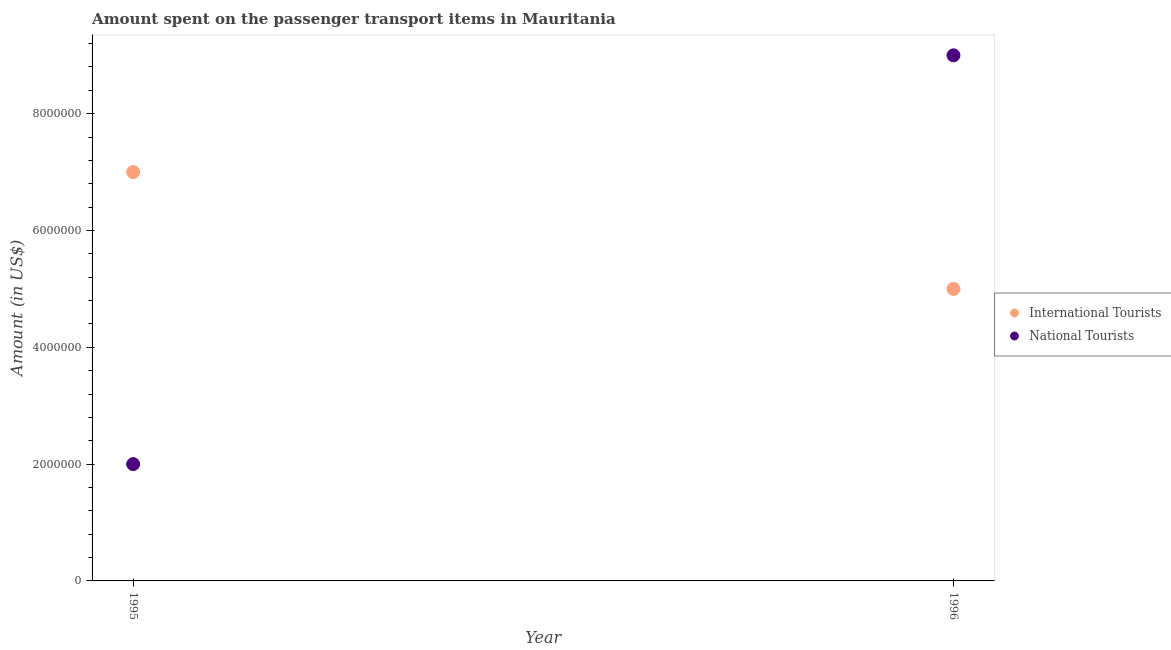How many different coloured dotlines are there?
Your answer should be very brief. 2. Is the number of dotlines equal to the number of legend labels?
Provide a short and direct response. Yes. What is the amount spent on transport items of international tourists in 1996?
Ensure brevity in your answer.  5.00e+06. Across all years, what is the maximum amount spent on transport items of international tourists?
Your answer should be very brief. 7.00e+06. Across all years, what is the minimum amount spent on transport items of international tourists?
Offer a terse response. 5.00e+06. In which year was the amount spent on transport items of international tourists maximum?
Provide a succinct answer. 1995. What is the total amount spent on transport items of national tourists in the graph?
Provide a short and direct response. 1.10e+07. What is the difference between the amount spent on transport items of national tourists in 1995 and that in 1996?
Keep it short and to the point. -7.00e+06. What is the difference between the amount spent on transport items of national tourists in 1996 and the amount spent on transport items of international tourists in 1995?
Offer a very short reply. 2.00e+06. What is the average amount spent on transport items of national tourists per year?
Provide a succinct answer. 5.50e+06. In the year 1996, what is the difference between the amount spent on transport items of international tourists and amount spent on transport items of national tourists?
Ensure brevity in your answer.  -4.00e+06. In how many years, is the amount spent on transport items of international tourists greater than 8800000 US$?
Offer a terse response. 0. What is the ratio of the amount spent on transport items of national tourists in 1995 to that in 1996?
Keep it short and to the point. 0.22. In how many years, is the amount spent on transport items of international tourists greater than the average amount spent on transport items of international tourists taken over all years?
Your answer should be compact. 1. Does the amount spent on transport items of international tourists monotonically increase over the years?
Give a very brief answer. No. Is the amount spent on transport items of international tourists strictly less than the amount spent on transport items of national tourists over the years?
Your response must be concise. No. How many dotlines are there?
Your response must be concise. 2. Are the values on the major ticks of Y-axis written in scientific E-notation?
Ensure brevity in your answer.  No. Does the graph contain grids?
Offer a terse response. No. How many legend labels are there?
Ensure brevity in your answer.  2. What is the title of the graph?
Provide a short and direct response. Amount spent on the passenger transport items in Mauritania. What is the label or title of the Y-axis?
Make the answer very short. Amount (in US$). What is the Amount (in US$) in International Tourists in 1995?
Your response must be concise. 7.00e+06. What is the Amount (in US$) of National Tourists in 1996?
Offer a terse response. 9.00e+06. Across all years, what is the maximum Amount (in US$) in National Tourists?
Provide a short and direct response. 9.00e+06. Across all years, what is the minimum Amount (in US$) of National Tourists?
Ensure brevity in your answer.  2.00e+06. What is the total Amount (in US$) of National Tourists in the graph?
Provide a succinct answer. 1.10e+07. What is the difference between the Amount (in US$) of National Tourists in 1995 and that in 1996?
Offer a terse response. -7.00e+06. What is the average Amount (in US$) of National Tourists per year?
Your answer should be compact. 5.50e+06. What is the ratio of the Amount (in US$) in International Tourists in 1995 to that in 1996?
Your response must be concise. 1.4. What is the ratio of the Amount (in US$) in National Tourists in 1995 to that in 1996?
Offer a very short reply. 0.22. What is the difference between the highest and the second highest Amount (in US$) of National Tourists?
Ensure brevity in your answer.  7.00e+06. What is the difference between the highest and the lowest Amount (in US$) of International Tourists?
Provide a succinct answer. 2.00e+06. 